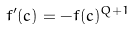Convert formula to latex. <formula><loc_0><loc_0><loc_500><loc_500>f ^ { \prime } ( c ) = - f ( c ) ^ { Q + 1 }</formula> 